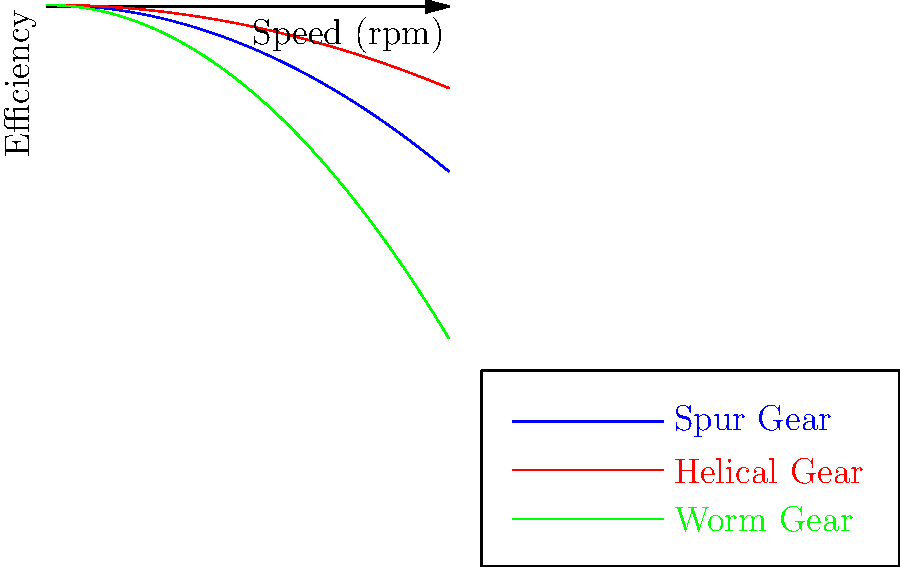As an information architect tasked with visualizing gear efficiency data, you're presented with the efficiency curves for spur, helical, and worm gears. Based on the graph, which gear type maintains the highest efficiency across the entire speed range, and what factors contribute to this superior performance? To answer this question, we need to analyze the efficiency curves for each gear type:

1. Observe the initial efficiencies (y-intercepts):
   - Spur gear: starts at about 98%
   - Helical gear: starts at about 99%
   - Worm gear: starts at about 85%

2. Examine the rate of efficiency decline (curve steepness):
   - Helical gear: shows the least decline
   - Spur gear: shows a moderate decline
   - Worm gear: shows the steepest decline

3. Compare the curves across the entire speed range:
   - The helical gear curve remains above both the spur and worm gear curves throughout the entire speed range.

4. Factors contributing to helical gear's superior performance:
   a) Higher initial efficiency due to smoother tooth engagement
   b) Gradual load distribution across multiple teeth
   c) Reduced friction due to the helical tooth profile
   d) Better lubrication retention between gear teeth

5. Conclusion:
   The helical gear maintains the highest efficiency across the entire speed range due to its design characteristics that minimize energy loss and friction.
Answer: Helical gear; smoother engagement, gradual load distribution, reduced friction, better lubrication. 